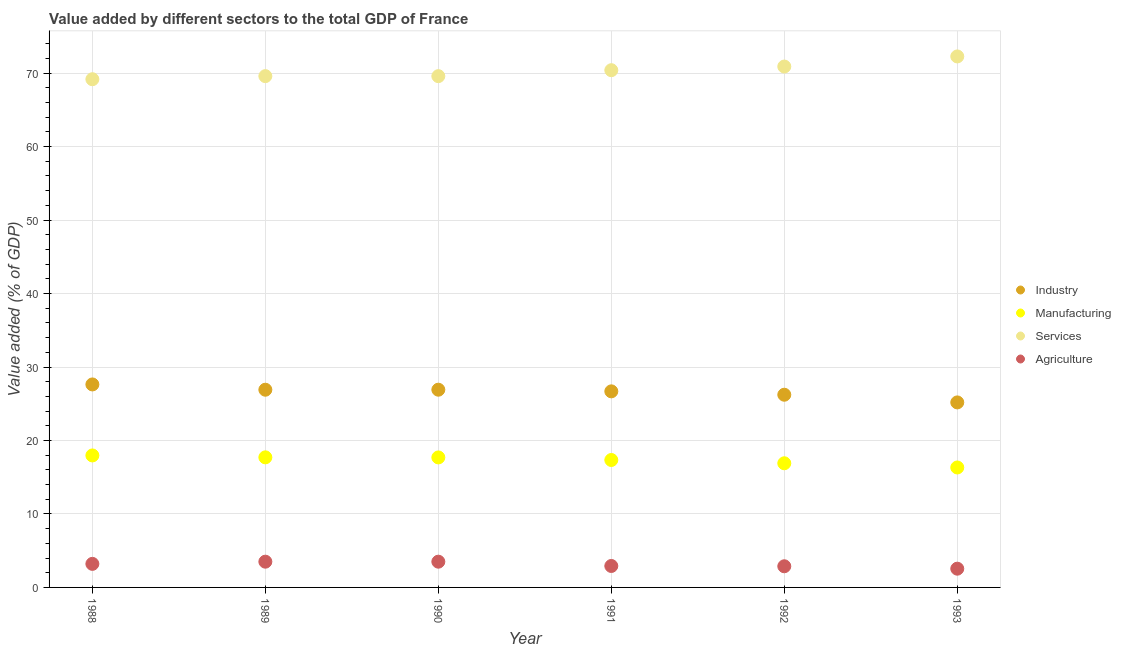How many different coloured dotlines are there?
Your answer should be very brief. 4. Is the number of dotlines equal to the number of legend labels?
Give a very brief answer. Yes. What is the value added by industrial sector in 1993?
Make the answer very short. 25.18. Across all years, what is the maximum value added by agricultural sector?
Ensure brevity in your answer.  3.5. Across all years, what is the minimum value added by agricultural sector?
Your answer should be compact. 2.55. In which year was the value added by industrial sector maximum?
Provide a succinct answer. 1988. What is the total value added by services sector in the graph?
Provide a succinct answer. 421.9. What is the difference between the value added by manufacturing sector in 1990 and that in 1993?
Your answer should be compact. 1.37. What is the difference between the value added by manufacturing sector in 1989 and the value added by services sector in 1991?
Your response must be concise. -52.69. What is the average value added by industrial sector per year?
Offer a very short reply. 26.59. In the year 1990, what is the difference between the value added by manufacturing sector and value added by agricultural sector?
Provide a succinct answer. 14.19. What is the ratio of the value added by services sector in 1990 to that in 1991?
Keep it short and to the point. 0.99. Is the value added by services sector in 1988 less than that in 1989?
Your response must be concise. Yes. Is the difference between the value added by industrial sector in 1988 and 1991 greater than the difference between the value added by services sector in 1988 and 1991?
Provide a succinct answer. Yes. What is the difference between the highest and the second highest value added by services sector?
Your answer should be very brief. 1.37. What is the difference between the highest and the lowest value added by industrial sector?
Provide a succinct answer. 2.45. In how many years, is the value added by services sector greater than the average value added by services sector taken over all years?
Your answer should be very brief. 3. Is it the case that in every year, the sum of the value added by industrial sector and value added by manufacturing sector is greater than the value added by services sector?
Offer a very short reply. No. Is the value added by agricultural sector strictly greater than the value added by manufacturing sector over the years?
Your answer should be compact. No. How many dotlines are there?
Give a very brief answer. 4. Are the values on the major ticks of Y-axis written in scientific E-notation?
Give a very brief answer. No. Where does the legend appear in the graph?
Your answer should be compact. Center right. How many legend labels are there?
Give a very brief answer. 4. What is the title of the graph?
Your answer should be compact. Value added by different sectors to the total GDP of France. What is the label or title of the X-axis?
Ensure brevity in your answer.  Year. What is the label or title of the Y-axis?
Offer a terse response. Value added (% of GDP). What is the Value added (% of GDP) in Industry in 1988?
Make the answer very short. 27.63. What is the Value added (% of GDP) in Manufacturing in 1988?
Keep it short and to the point. 17.96. What is the Value added (% of GDP) in Services in 1988?
Your answer should be compact. 69.17. What is the Value added (% of GDP) in Agriculture in 1988?
Your answer should be compact. 3.21. What is the Value added (% of GDP) of Industry in 1989?
Make the answer very short. 26.91. What is the Value added (% of GDP) in Manufacturing in 1989?
Offer a very short reply. 17.7. What is the Value added (% of GDP) of Services in 1989?
Provide a short and direct response. 69.59. What is the Value added (% of GDP) in Agriculture in 1989?
Ensure brevity in your answer.  3.5. What is the Value added (% of GDP) of Industry in 1990?
Make the answer very short. 26.91. What is the Value added (% of GDP) of Manufacturing in 1990?
Offer a very short reply. 17.69. What is the Value added (% of GDP) of Services in 1990?
Ensure brevity in your answer.  69.59. What is the Value added (% of GDP) in Agriculture in 1990?
Your response must be concise. 3.5. What is the Value added (% of GDP) in Industry in 1991?
Your answer should be compact. 26.69. What is the Value added (% of GDP) of Manufacturing in 1991?
Keep it short and to the point. 17.34. What is the Value added (% of GDP) in Services in 1991?
Your answer should be very brief. 70.4. What is the Value added (% of GDP) in Agriculture in 1991?
Your answer should be very brief. 2.92. What is the Value added (% of GDP) of Industry in 1992?
Keep it short and to the point. 26.23. What is the Value added (% of GDP) in Manufacturing in 1992?
Make the answer very short. 16.9. What is the Value added (% of GDP) of Services in 1992?
Your answer should be compact. 70.89. What is the Value added (% of GDP) of Agriculture in 1992?
Keep it short and to the point. 2.88. What is the Value added (% of GDP) of Industry in 1993?
Your response must be concise. 25.18. What is the Value added (% of GDP) of Manufacturing in 1993?
Give a very brief answer. 16.32. What is the Value added (% of GDP) of Services in 1993?
Your answer should be very brief. 72.27. What is the Value added (% of GDP) in Agriculture in 1993?
Provide a short and direct response. 2.55. Across all years, what is the maximum Value added (% of GDP) in Industry?
Your answer should be compact. 27.63. Across all years, what is the maximum Value added (% of GDP) in Manufacturing?
Offer a terse response. 17.96. Across all years, what is the maximum Value added (% of GDP) of Services?
Your answer should be very brief. 72.27. Across all years, what is the maximum Value added (% of GDP) of Agriculture?
Your answer should be very brief. 3.5. Across all years, what is the minimum Value added (% of GDP) of Industry?
Ensure brevity in your answer.  25.18. Across all years, what is the minimum Value added (% of GDP) in Manufacturing?
Give a very brief answer. 16.32. Across all years, what is the minimum Value added (% of GDP) of Services?
Keep it short and to the point. 69.17. Across all years, what is the minimum Value added (% of GDP) of Agriculture?
Your answer should be compact. 2.55. What is the total Value added (% of GDP) of Industry in the graph?
Ensure brevity in your answer.  159.54. What is the total Value added (% of GDP) of Manufacturing in the graph?
Provide a short and direct response. 103.92. What is the total Value added (% of GDP) in Services in the graph?
Your response must be concise. 421.9. What is the total Value added (% of GDP) in Agriculture in the graph?
Your response must be concise. 18.56. What is the difference between the Value added (% of GDP) of Industry in 1988 and that in 1989?
Your answer should be very brief. 0.72. What is the difference between the Value added (% of GDP) of Manufacturing in 1988 and that in 1989?
Provide a short and direct response. 0.26. What is the difference between the Value added (% of GDP) in Services in 1988 and that in 1989?
Your response must be concise. -0.42. What is the difference between the Value added (% of GDP) of Agriculture in 1988 and that in 1989?
Your answer should be compact. -0.3. What is the difference between the Value added (% of GDP) of Industry in 1988 and that in 1990?
Offer a terse response. 0.72. What is the difference between the Value added (% of GDP) in Manufacturing in 1988 and that in 1990?
Offer a very short reply. 0.27. What is the difference between the Value added (% of GDP) of Services in 1988 and that in 1990?
Your response must be concise. -0.42. What is the difference between the Value added (% of GDP) of Agriculture in 1988 and that in 1990?
Offer a very short reply. -0.3. What is the difference between the Value added (% of GDP) of Industry in 1988 and that in 1991?
Offer a terse response. 0.94. What is the difference between the Value added (% of GDP) of Manufacturing in 1988 and that in 1991?
Give a very brief answer. 0.62. What is the difference between the Value added (% of GDP) in Services in 1988 and that in 1991?
Your answer should be compact. -1.23. What is the difference between the Value added (% of GDP) in Agriculture in 1988 and that in 1991?
Offer a very short reply. 0.29. What is the difference between the Value added (% of GDP) of Industry in 1988 and that in 1992?
Give a very brief answer. 1.4. What is the difference between the Value added (% of GDP) in Manufacturing in 1988 and that in 1992?
Keep it short and to the point. 1.07. What is the difference between the Value added (% of GDP) of Services in 1988 and that in 1992?
Offer a terse response. -1.73. What is the difference between the Value added (% of GDP) in Agriculture in 1988 and that in 1992?
Give a very brief answer. 0.33. What is the difference between the Value added (% of GDP) of Industry in 1988 and that in 1993?
Keep it short and to the point. 2.45. What is the difference between the Value added (% of GDP) in Manufacturing in 1988 and that in 1993?
Offer a terse response. 1.64. What is the difference between the Value added (% of GDP) in Services in 1988 and that in 1993?
Ensure brevity in your answer.  -3.1. What is the difference between the Value added (% of GDP) in Agriculture in 1988 and that in 1993?
Provide a succinct answer. 0.66. What is the difference between the Value added (% of GDP) in Industry in 1989 and that in 1990?
Provide a succinct answer. -0. What is the difference between the Value added (% of GDP) in Manufacturing in 1989 and that in 1990?
Make the answer very short. 0.01. What is the difference between the Value added (% of GDP) in Services in 1989 and that in 1990?
Offer a terse response. 0. What is the difference between the Value added (% of GDP) of Agriculture in 1989 and that in 1990?
Keep it short and to the point. -0. What is the difference between the Value added (% of GDP) of Industry in 1989 and that in 1991?
Ensure brevity in your answer.  0.22. What is the difference between the Value added (% of GDP) in Manufacturing in 1989 and that in 1991?
Your response must be concise. 0.36. What is the difference between the Value added (% of GDP) in Services in 1989 and that in 1991?
Keep it short and to the point. -0.81. What is the difference between the Value added (% of GDP) of Agriculture in 1989 and that in 1991?
Ensure brevity in your answer.  0.58. What is the difference between the Value added (% of GDP) in Industry in 1989 and that in 1992?
Make the answer very short. 0.68. What is the difference between the Value added (% of GDP) of Manufacturing in 1989 and that in 1992?
Your response must be concise. 0.81. What is the difference between the Value added (% of GDP) in Services in 1989 and that in 1992?
Ensure brevity in your answer.  -1.31. What is the difference between the Value added (% of GDP) in Agriculture in 1989 and that in 1992?
Your answer should be very brief. 0.62. What is the difference between the Value added (% of GDP) of Industry in 1989 and that in 1993?
Make the answer very short. 1.73. What is the difference between the Value added (% of GDP) in Manufacturing in 1989 and that in 1993?
Your answer should be compact. 1.38. What is the difference between the Value added (% of GDP) in Services in 1989 and that in 1993?
Your answer should be very brief. -2.68. What is the difference between the Value added (% of GDP) in Agriculture in 1989 and that in 1993?
Your response must be concise. 0.95. What is the difference between the Value added (% of GDP) of Industry in 1990 and that in 1991?
Provide a succinct answer. 0.22. What is the difference between the Value added (% of GDP) of Manufacturing in 1990 and that in 1991?
Offer a terse response. 0.35. What is the difference between the Value added (% of GDP) of Services in 1990 and that in 1991?
Provide a short and direct response. -0.81. What is the difference between the Value added (% of GDP) in Agriculture in 1990 and that in 1991?
Your answer should be compact. 0.59. What is the difference between the Value added (% of GDP) of Industry in 1990 and that in 1992?
Provide a succinct answer. 0.68. What is the difference between the Value added (% of GDP) of Manufacturing in 1990 and that in 1992?
Make the answer very short. 0.8. What is the difference between the Value added (% of GDP) in Services in 1990 and that in 1992?
Your answer should be compact. -1.31. What is the difference between the Value added (% of GDP) in Agriculture in 1990 and that in 1992?
Your response must be concise. 0.62. What is the difference between the Value added (% of GDP) in Industry in 1990 and that in 1993?
Provide a succinct answer. 1.73. What is the difference between the Value added (% of GDP) of Manufacturing in 1990 and that in 1993?
Your answer should be compact. 1.37. What is the difference between the Value added (% of GDP) of Services in 1990 and that in 1993?
Give a very brief answer. -2.68. What is the difference between the Value added (% of GDP) of Agriculture in 1990 and that in 1993?
Give a very brief answer. 0.95. What is the difference between the Value added (% of GDP) in Industry in 1991 and that in 1992?
Make the answer very short. 0.46. What is the difference between the Value added (% of GDP) in Manufacturing in 1991 and that in 1992?
Provide a short and direct response. 0.45. What is the difference between the Value added (% of GDP) in Services in 1991 and that in 1992?
Your answer should be very brief. -0.5. What is the difference between the Value added (% of GDP) of Agriculture in 1991 and that in 1992?
Offer a very short reply. 0.04. What is the difference between the Value added (% of GDP) of Industry in 1991 and that in 1993?
Provide a succinct answer. 1.5. What is the difference between the Value added (% of GDP) of Manufacturing in 1991 and that in 1993?
Ensure brevity in your answer.  1.02. What is the difference between the Value added (% of GDP) of Services in 1991 and that in 1993?
Provide a succinct answer. -1.87. What is the difference between the Value added (% of GDP) in Agriculture in 1991 and that in 1993?
Make the answer very short. 0.37. What is the difference between the Value added (% of GDP) in Industry in 1992 and that in 1993?
Ensure brevity in your answer.  1.04. What is the difference between the Value added (% of GDP) in Manufacturing in 1992 and that in 1993?
Ensure brevity in your answer.  0.57. What is the difference between the Value added (% of GDP) in Services in 1992 and that in 1993?
Offer a very short reply. -1.37. What is the difference between the Value added (% of GDP) in Agriculture in 1992 and that in 1993?
Keep it short and to the point. 0.33. What is the difference between the Value added (% of GDP) in Industry in 1988 and the Value added (% of GDP) in Manufacturing in 1989?
Provide a short and direct response. 9.92. What is the difference between the Value added (% of GDP) of Industry in 1988 and the Value added (% of GDP) of Services in 1989?
Your answer should be compact. -41.96. What is the difference between the Value added (% of GDP) of Industry in 1988 and the Value added (% of GDP) of Agriculture in 1989?
Provide a short and direct response. 24.12. What is the difference between the Value added (% of GDP) in Manufacturing in 1988 and the Value added (% of GDP) in Services in 1989?
Make the answer very short. -51.63. What is the difference between the Value added (% of GDP) of Manufacturing in 1988 and the Value added (% of GDP) of Agriculture in 1989?
Your answer should be very brief. 14.46. What is the difference between the Value added (% of GDP) in Services in 1988 and the Value added (% of GDP) in Agriculture in 1989?
Offer a very short reply. 65.66. What is the difference between the Value added (% of GDP) of Industry in 1988 and the Value added (% of GDP) of Manufacturing in 1990?
Your response must be concise. 9.93. What is the difference between the Value added (% of GDP) of Industry in 1988 and the Value added (% of GDP) of Services in 1990?
Your answer should be very brief. -41.96. What is the difference between the Value added (% of GDP) in Industry in 1988 and the Value added (% of GDP) in Agriculture in 1990?
Keep it short and to the point. 24.12. What is the difference between the Value added (% of GDP) in Manufacturing in 1988 and the Value added (% of GDP) in Services in 1990?
Offer a very short reply. -51.62. What is the difference between the Value added (% of GDP) in Manufacturing in 1988 and the Value added (% of GDP) in Agriculture in 1990?
Provide a succinct answer. 14.46. What is the difference between the Value added (% of GDP) of Services in 1988 and the Value added (% of GDP) of Agriculture in 1990?
Keep it short and to the point. 65.66. What is the difference between the Value added (% of GDP) in Industry in 1988 and the Value added (% of GDP) in Manufacturing in 1991?
Offer a terse response. 10.28. What is the difference between the Value added (% of GDP) of Industry in 1988 and the Value added (% of GDP) of Services in 1991?
Make the answer very short. -42.77. What is the difference between the Value added (% of GDP) of Industry in 1988 and the Value added (% of GDP) of Agriculture in 1991?
Your response must be concise. 24.71. What is the difference between the Value added (% of GDP) in Manufacturing in 1988 and the Value added (% of GDP) in Services in 1991?
Give a very brief answer. -52.43. What is the difference between the Value added (% of GDP) of Manufacturing in 1988 and the Value added (% of GDP) of Agriculture in 1991?
Your answer should be very brief. 15.04. What is the difference between the Value added (% of GDP) of Services in 1988 and the Value added (% of GDP) of Agriculture in 1991?
Make the answer very short. 66.25. What is the difference between the Value added (% of GDP) in Industry in 1988 and the Value added (% of GDP) in Manufacturing in 1992?
Offer a terse response. 10.73. What is the difference between the Value added (% of GDP) of Industry in 1988 and the Value added (% of GDP) of Services in 1992?
Offer a terse response. -43.27. What is the difference between the Value added (% of GDP) of Industry in 1988 and the Value added (% of GDP) of Agriculture in 1992?
Provide a short and direct response. 24.75. What is the difference between the Value added (% of GDP) of Manufacturing in 1988 and the Value added (% of GDP) of Services in 1992?
Ensure brevity in your answer.  -52.93. What is the difference between the Value added (% of GDP) in Manufacturing in 1988 and the Value added (% of GDP) in Agriculture in 1992?
Provide a succinct answer. 15.08. What is the difference between the Value added (% of GDP) of Services in 1988 and the Value added (% of GDP) of Agriculture in 1992?
Keep it short and to the point. 66.29. What is the difference between the Value added (% of GDP) of Industry in 1988 and the Value added (% of GDP) of Manufacturing in 1993?
Provide a succinct answer. 11.3. What is the difference between the Value added (% of GDP) in Industry in 1988 and the Value added (% of GDP) in Services in 1993?
Offer a very short reply. -44.64. What is the difference between the Value added (% of GDP) in Industry in 1988 and the Value added (% of GDP) in Agriculture in 1993?
Offer a terse response. 25.08. What is the difference between the Value added (% of GDP) in Manufacturing in 1988 and the Value added (% of GDP) in Services in 1993?
Provide a short and direct response. -54.31. What is the difference between the Value added (% of GDP) of Manufacturing in 1988 and the Value added (% of GDP) of Agriculture in 1993?
Your answer should be compact. 15.41. What is the difference between the Value added (% of GDP) of Services in 1988 and the Value added (% of GDP) of Agriculture in 1993?
Your answer should be compact. 66.62. What is the difference between the Value added (% of GDP) of Industry in 1989 and the Value added (% of GDP) of Manufacturing in 1990?
Provide a short and direct response. 9.22. What is the difference between the Value added (% of GDP) in Industry in 1989 and the Value added (% of GDP) in Services in 1990?
Give a very brief answer. -42.68. What is the difference between the Value added (% of GDP) of Industry in 1989 and the Value added (% of GDP) of Agriculture in 1990?
Keep it short and to the point. 23.4. What is the difference between the Value added (% of GDP) in Manufacturing in 1989 and the Value added (% of GDP) in Services in 1990?
Keep it short and to the point. -51.88. What is the difference between the Value added (% of GDP) in Manufacturing in 1989 and the Value added (% of GDP) in Agriculture in 1990?
Give a very brief answer. 14.2. What is the difference between the Value added (% of GDP) of Services in 1989 and the Value added (% of GDP) of Agriculture in 1990?
Make the answer very short. 66.08. What is the difference between the Value added (% of GDP) in Industry in 1989 and the Value added (% of GDP) in Manufacturing in 1991?
Your answer should be compact. 9.56. What is the difference between the Value added (% of GDP) of Industry in 1989 and the Value added (% of GDP) of Services in 1991?
Your response must be concise. -43.49. What is the difference between the Value added (% of GDP) in Industry in 1989 and the Value added (% of GDP) in Agriculture in 1991?
Ensure brevity in your answer.  23.99. What is the difference between the Value added (% of GDP) in Manufacturing in 1989 and the Value added (% of GDP) in Services in 1991?
Provide a succinct answer. -52.69. What is the difference between the Value added (% of GDP) in Manufacturing in 1989 and the Value added (% of GDP) in Agriculture in 1991?
Offer a terse response. 14.79. What is the difference between the Value added (% of GDP) of Services in 1989 and the Value added (% of GDP) of Agriculture in 1991?
Provide a short and direct response. 66.67. What is the difference between the Value added (% of GDP) in Industry in 1989 and the Value added (% of GDP) in Manufacturing in 1992?
Your answer should be very brief. 10.01. What is the difference between the Value added (% of GDP) of Industry in 1989 and the Value added (% of GDP) of Services in 1992?
Ensure brevity in your answer.  -43.99. What is the difference between the Value added (% of GDP) of Industry in 1989 and the Value added (% of GDP) of Agriculture in 1992?
Provide a short and direct response. 24.03. What is the difference between the Value added (% of GDP) of Manufacturing in 1989 and the Value added (% of GDP) of Services in 1992?
Keep it short and to the point. -53.19. What is the difference between the Value added (% of GDP) in Manufacturing in 1989 and the Value added (% of GDP) in Agriculture in 1992?
Offer a terse response. 14.82. What is the difference between the Value added (% of GDP) of Services in 1989 and the Value added (% of GDP) of Agriculture in 1992?
Make the answer very short. 66.71. What is the difference between the Value added (% of GDP) of Industry in 1989 and the Value added (% of GDP) of Manufacturing in 1993?
Keep it short and to the point. 10.58. What is the difference between the Value added (% of GDP) in Industry in 1989 and the Value added (% of GDP) in Services in 1993?
Keep it short and to the point. -45.36. What is the difference between the Value added (% of GDP) of Industry in 1989 and the Value added (% of GDP) of Agriculture in 1993?
Make the answer very short. 24.36. What is the difference between the Value added (% of GDP) of Manufacturing in 1989 and the Value added (% of GDP) of Services in 1993?
Your answer should be very brief. -54.56. What is the difference between the Value added (% of GDP) in Manufacturing in 1989 and the Value added (% of GDP) in Agriculture in 1993?
Your response must be concise. 15.15. What is the difference between the Value added (% of GDP) in Services in 1989 and the Value added (% of GDP) in Agriculture in 1993?
Offer a terse response. 67.04. What is the difference between the Value added (% of GDP) in Industry in 1990 and the Value added (% of GDP) in Manufacturing in 1991?
Keep it short and to the point. 9.57. What is the difference between the Value added (% of GDP) of Industry in 1990 and the Value added (% of GDP) of Services in 1991?
Provide a succinct answer. -43.48. What is the difference between the Value added (% of GDP) in Industry in 1990 and the Value added (% of GDP) in Agriculture in 1991?
Offer a terse response. 23.99. What is the difference between the Value added (% of GDP) of Manufacturing in 1990 and the Value added (% of GDP) of Services in 1991?
Give a very brief answer. -52.7. What is the difference between the Value added (% of GDP) of Manufacturing in 1990 and the Value added (% of GDP) of Agriculture in 1991?
Ensure brevity in your answer.  14.77. What is the difference between the Value added (% of GDP) in Services in 1990 and the Value added (% of GDP) in Agriculture in 1991?
Keep it short and to the point. 66.67. What is the difference between the Value added (% of GDP) of Industry in 1990 and the Value added (% of GDP) of Manufacturing in 1992?
Ensure brevity in your answer.  10.01. What is the difference between the Value added (% of GDP) in Industry in 1990 and the Value added (% of GDP) in Services in 1992?
Your answer should be very brief. -43.98. What is the difference between the Value added (% of GDP) of Industry in 1990 and the Value added (% of GDP) of Agriculture in 1992?
Keep it short and to the point. 24.03. What is the difference between the Value added (% of GDP) in Manufacturing in 1990 and the Value added (% of GDP) in Services in 1992?
Give a very brief answer. -53.2. What is the difference between the Value added (% of GDP) of Manufacturing in 1990 and the Value added (% of GDP) of Agriculture in 1992?
Ensure brevity in your answer.  14.81. What is the difference between the Value added (% of GDP) in Services in 1990 and the Value added (% of GDP) in Agriculture in 1992?
Keep it short and to the point. 66.71. What is the difference between the Value added (% of GDP) of Industry in 1990 and the Value added (% of GDP) of Manufacturing in 1993?
Your answer should be compact. 10.59. What is the difference between the Value added (% of GDP) of Industry in 1990 and the Value added (% of GDP) of Services in 1993?
Offer a terse response. -45.36. What is the difference between the Value added (% of GDP) in Industry in 1990 and the Value added (% of GDP) in Agriculture in 1993?
Make the answer very short. 24.36. What is the difference between the Value added (% of GDP) of Manufacturing in 1990 and the Value added (% of GDP) of Services in 1993?
Provide a succinct answer. -54.58. What is the difference between the Value added (% of GDP) in Manufacturing in 1990 and the Value added (% of GDP) in Agriculture in 1993?
Ensure brevity in your answer.  15.14. What is the difference between the Value added (% of GDP) in Services in 1990 and the Value added (% of GDP) in Agriculture in 1993?
Make the answer very short. 67.03. What is the difference between the Value added (% of GDP) in Industry in 1991 and the Value added (% of GDP) in Manufacturing in 1992?
Your response must be concise. 9.79. What is the difference between the Value added (% of GDP) of Industry in 1991 and the Value added (% of GDP) of Services in 1992?
Give a very brief answer. -44.21. What is the difference between the Value added (% of GDP) in Industry in 1991 and the Value added (% of GDP) in Agriculture in 1992?
Provide a short and direct response. 23.81. What is the difference between the Value added (% of GDP) in Manufacturing in 1991 and the Value added (% of GDP) in Services in 1992?
Your answer should be compact. -53.55. What is the difference between the Value added (% of GDP) in Manufacturing in 1991 and the Value added (% of GDP) in Agriculture in 1992?
Provide a short and direct response. 14.46. What is the difference between the Value added (% of GDP) of Services in 1991 and the Value added (% of GDP) of Agriculture in 1992?
Provide a short and direct response. 67.52. What is the difference between the Value added (% of GDP) in Industry in 1991 and the Value added (% of GDP) in Manufacturing in 1993?
Your response must be concise. 10.36. What is the difference between the Value added (% of GDP) of Industry in 1991 and the Value added (% of GDP) of Services in 1993?
Your response must be concise. -45.58. What is the difference between the Value added (% of GDP) in Industry in 1991 and the Value added (% of GDP) in Agriculture in 1993?
Offer a very short reply. 24.14. What is the difference between the Value added (% of GDP) in Manufacturing in 1991 and the Value added (% of GDP) in Services in 1993?
Offer a terse response. -54.93. What is the difference between the Value added (% of GDP) of Manufacturing in 1991 and the Value added (% of GDP) of Agriculture in 1993?
Your response must be concise. 14.79. What is the difference between the Value added (% of GDP) of Services in 1991 and the Value added (% of GDP) of Agriculture in 1993?
Keep it short and to the point. 67.84. What is the difference between the Value added (% of GDP) of Industry in 1992 and the Value added (% of GDP) of Manufacturing in 1993?
Provide a succinct answer. 9.9. What is the difference between the Value added (% of GDP) in Industry in 1992 and the Value added (% of GDP) in Services in 1993?
Provide a succinct answer. -46.04. What is the difference between the Value added (% of GDP) in Industry in 1992 and the Value added (% of GDP) in Agriculture in 1993?
Your answer should be compact. 23.68. What is the difference between the Value added (% of GDP) of Manufacturing in 1992 and the Value added (% of GDP) of Services in 1993?
Provide a short and direct response. -55.37. What is the difference between the Value added (% of GDP) in Manufacturing in 1992 and the Value added (% of GDP) in Agriculture in 1993?
Offer a terse response. 14.35. What is the difference between the Value added (% of GDP) of Services in 1992 and the Value added (% of GDP) of Agriculture in 1993?
Ensure brevity in your answer.  68.34. What is the average Value added (% of GDP) in Industry per year?
Your answer should be compact. 26.59. What is the average Value added (% of GDP) of Manufacturing per year?
Provide a short and direct response. 17.32. What is the average Value added (% of GDP) of Services per year?
Your response must be concise. 70.32. What is the average Value added (% of GDP) in Agriculture per year?
Give a very brief answer. 3.09. In the year 1988, what is the difference between the Value added (% of GDP) in Industry and Value added (% of GDP) in Manufacturing?
Offer a very short reply. 9.66. In the year 1988, what is the difference between the Value added (% of GDP) of Industry and Value added (% of GDP) of Services?
Give a very brief answer. -41.54. In the year 1988, what is the difference between the Value added (% of GDP) in Industry and Value added (% of GDP) in Agriculture?
Your answer should be compact. 24.42. In the year 1988, what is the difference between the Value added (% of GDP) of Manufacturing and Value added (% of GDP) of Services?
Your answer should be compact. -51.2. In the year 1988, what is the difference between the Value added (% of GDP) in Manufacturing and Value added (% of GDP) in Agriculture?
Give a very brief answer. 14.76. In the year 1988, what is the difference between the Value added (% of GDP) of Services and Value added (% of GDP) of Agriculture?
Offer a very short reply. 65.96. In the year 1989, what is the difference between the Value added (% of GDP) in Industry and Value added (% of GDP) in Manufacturing?
Offer a terse response. 9.2. In the year 1989, what is the difference between the Value added (% of GDP) in Industry and Value added (% of GDP) in Services?
Offer a terse response. -42.68. In the year 1989, what is the difference between the Value added (% of GDP) in Industry and Value added (% of GDP) in Agriculture?
Offer a very short reply. 23.4. In the year 1989, what is the difference between the Value added (% of GDP) in Manufacturing and Value added (% of GDP) in Services?
Your response must be concise. -51.88. In the year 1989, what is the difference between the Value added (% of GDP) in Manufacturing and Value added (% of GDP) in Agriculture?
Give a very brief answer. 14.2. In the year 1989, what is the difference between the Value added (% of GDP) of Services and Value added (% of GDP) of Agriculture?
Make the answer very short. 66.09. In the year 1990, what is the difference between the Value added (% of GDP) in Industry and Value added (% of GDP) in Manufacturing?
Ensure brevity in your answer.  9.22. In the year 1990, what is the difference between the Value added (% of GDP) in Industry and Value added (% of GDP) in Services?
Keep it short and to the point. -42.67. In the year 1990, what is the difference between the Value added (% of GDP) in Industry and Value added (% of GDP) in Agriculture?
Make the answer very short. 23.41. In the year 1990, what is the difference between the Value added (% of GDP) of Manufacturing and Value added (% of GDP) of Services?
Offer a terse response. -51.89. In the year 1990, what is the difference between the Value added (% of GDP) of Manufacturing and Value added (% of GDP) of Agriculture?
Ensure brevity in your answer.  14.19. In the year 1990, what is the difference between the Value added (% of GDP) in Services and Value added (% of GDP) in Agriculture?
Give a very brief answer. 66.08. In the year 1991, what is the difference between the Value added (% of GDP) of Industry and Value added (% of GDP) of Manufacturing?
Your response must be concise. 9.34. In the year 1991, what is the difference between the Value added (% of GDP) in Industry and Value added (% of GDP) in Services?
Provide a short and direct response. -43.71. In the year 1991, what is the difference between the Value added (% of GDP) of Industry and Value added (% of GDP) of Agriculture?
Your answer should be compact. 23.77. In the year 1991, what is the difference between the Value added (% of GDP) of Manufacturing and Value added (% of GDP) of Services?
Offer a very short reply. -53.05. In the year 1991, what is the difference between the Value added (% of GDP) in Manufacturing and Value added (% of GDP) in Agriculture?
Offer a very short reply. 14.42. In the year 1991, what is the difference between the Value added (% of GDP) of Services and Value added (% of GDP) of Agriculture?
Offer a terse response. 67.48. In the year 1992, what is the difference between the Value added (% of GDP) of Industry and Value added (% of GDP) of Manufacturing?
Your answer should be very brief. 9.33. In the year 1992, what is the difference between the Value added (% of GDP) in Industry and Value added (% of GDP) in Services?
Ensure brevity in your answer.  -44.67. In the year 1992, what is the difference between the Value added (% of GDP) in Industry and Value added (% of GDP) in Agriculture?
Your answer should be very brief. 23.35. In the year 1992, what is the difference between the Value added (% of GDP) of Manufacturing and Value added (% of GDP) of Services?
Your response must be concise. -54. In the year 1992, what is the difference between the Value added (% of GDP) of Manufacturing and Value added (% of GDP) of Agriculture?
Your answer should be compact. 14.02. In the year 1992, what is the difference between the Value added (% of GDP) in Services and Value added (% of GDP) in Agriculture?
Offer a terse response. 68.01. In the year 1993, what is the difference between the Value added (% of GDP) of Industry and Value added (% of GDP) of Manufacturing?
Keep it short and to the point. 8.86. In the year 1993, what is the difference between the Value added (% of GDP) of Industry and Value added (% of GDP) of Services?
Give a very brief answer. -47.09. In the year 1993, what is the difference between the Value added (% of GDP) in Industry and Value added (% of GDP) in Agriculture?
Keep it short and to the point. 22.63. In the year 1993, what is the difference between the Value added (% of GDP) of Manufacturing and Value added (% of GDP) of Services?
Offer a very short reply. -55.94. In the year 1993, what is the difference between the Value added (% of GDP) in Manufacturing and Value added (% of GDP) in Agriculture?
Your response must be concise. 13.77. In the year 1993, what is the difference between the Value added (% of GDP) of Services and Value added (% of GDP) of Agriculture?
Keep it short and to the point. 69.72. What is the ratio of the Value added (% of GDP) in Industry in 1988 to that in 1989?
Provide a short and direct response. 1.03. What is the ratio of the Value added (% of GDP) in Manufacturing in 1988 to that in 1989?
Ensure brevity in your answer.  1.01. What is the ratio of the Value added (% of GDP) of Services in 1988 to that in 1989?
Give a very brief answer. 0.99. What is the ratio of the Value added (% of GDP) in Agriculture in 1988 to that in 1989?
Offer a very short reply. 0.92. What is the ratio of the Value added (% of GDP) in Industry in 1988 to that in 1990?
Provide a succinct answer. 1.03. What is the ratio of the Value added (% of GDP) of Manufacturing in 1988 to that in 1990?
Offer a terse response. 1.02. What is the ratio of the Value added (% of GDP) of Agriculture in 1988 to that in 1990?
Offer a terse response. 0.92. What is the ratio of the Value added (% of GDP) of Industry in 1988 to that in 1991?
Provide a short and direct response. 1.04. What is the ratio of the Value added (% of GDP) of Manufacturing in 1988 to that in 1991?
Ensure brevity in your answer.  1.04. What is the ratio of the Value added (% of GDP) in Services in 1988 to that in 1991?
Provide a short and direct response. 0.98. What is the ratio of the Value added (% of GDP) in Agriculture in 1988 to that in 1991?
Provide a short and direct response. 1.1. What is the ratio of the Value added (% of GDP) in Industry in 1988 to that in 1992?
Your answer should be compact. 1.05. What is the ratio of the Value added (% of GDP) in Manufacturing in 1988 to that in 1992?
Keep it short and to the point. 1.06. What is the ratio of the Value added (% of GDP) of Services in 1988 to that in 1992?
Your answer should be compact. 0.98. What is the ratio of the Value added (% of GDP) in Agriculture in 1988 to that in 1992?
Your answer should be compact. 1.11. What is the ratio of the Value added (% of GDP) of Industry in 1988 to that in 1993?
Ensure brevity in your answer.  1.1. What is the ratio of the Value added (% of GDP) of Manufacturing in 1988 to that in 1993?
Offer a terse response. 1.1. What is the ratio of the Value added (% of GDP) in Services in 1988 to that in 1993?
Give a very brief answer. 0.96. What is the ratio of the Value added (% of GDP) of Agriculture in 1988 to that in 1993?
Offer a very short reply. 1.26. What is the ratio of the Value added (% of GDP) of Industry in 1989 to that in 1990?
Give a very brief answer. 1. What is the ratio of the Value added (% of GDP) of Services in 1989 to that in 1990?
Offer a terse response. 1. What is the ratio of the Value added (% of GDP) in Industry in 1989 to that in 1991?
Keep it short and to the point. 1.01. What is the ratio of the Value added (% of GDP) in Manufacturing in 1989 to that in 1991?
Ensure brevity in your answer.  1.02. What is the ratio of the Value added (% of GDP) in Agriculture in 1989 to that in 1991?
Give a very brief answer. 1.2. What is the ratio of the Value added (% of GDP) in Industry in 1989 to that in 1992?
Provide a short and direct response. 1.03. What is the ratio of the Value added (% of GDP) of Manufacturing in 1989 to that in 1992?
Ensure brevity in your answer.  1.05. What is the ratio of the Value added (% of GDP) in Services in 1989 to that in 1992?
Give a very brief answer. 0.98. What is the ratio of the Value added (% of GDP) in Agriculture in 1989 to that in 1992?
Provide a short and direct response. 1.22. What is the ratio of the Value added (% of GDP) in Industry in 1989 to that in 1993?
Provide a short and direct response. 1.07. What is the ratio of the Value added (% of GDP) in Manufacturing in 1989 to that in 1993?
Provide a short and direct response. 1.08. What is the ratio of the Value added (% of GDP) in Services in 1989 to that in 1993?
Your response must be concise. 0.96. What is the ratio of the Value added (% of GDP) in Agriculture in 1989 to that in 1993?
Keep it short and to the point. 1.37. What is the ratio of the Value added (% of GDP) in Industry in 1990 to that in 1991?
Your answer should be compact. 1.01. What is the ratio of the Value added (% of GDP) in Manufacturing in 1990 to that in 1991?
Provide a succinct answer. 1.02. What is the ratio of the Value added (% of GDP) in Services in 1990 to that in 1991?
Your response must be concise. 0.99. What is the ratio of the Value added (% of GDP) in Agriculture in 1990 to that in 1991?
Your response must be concise. 1.2. What is the ratio of the Value added (% of GDP) of Industry in 1990 to that in 1992?
Make the answer very short. 1.03. What is the ratio of the Value added (% of GDP) of Manufacturing in 1990 to that in 1992?
Keep it short and to the point. 1.05. What is the ratio of the Value added (% of GDP) of Services in 1990 to that in 1992?
Offer a very short reply. 0.98. What is the ratio of the Value added (% of GDP) of Agriculture in 1990 to that in 1992?
Your answer should be very brief. 1.22. What is the ratio of the Value added (% of GDP) of Industry in 1990 to that in 1993?
Provide a short and direct response. 1.07. What is the ratio of the Value added (% of GDP) in Manufacturing in 1990 to that in 1993?
Ensure brevity in your answer.  1.08. What is the ratio of the Value added (% of GDP) of Services in 1990 to that in 1993?
Offer a very short reply. 0.96. What is the ratio of the Value added (% of GDP) of Agriculture in 1990 to that in 1993?
Ensure brevity in your answer.  1.37. What is the ratio of the Value added (% of GDP) in Industry in 1991 to that in 1992?
Keep it short and to the point. 1.02. What is the ratio of the Value added (% of GDP) in Manufacturing in 1991 to that in 1992?
Your response must be concise. 1.03. What is the ratio of the Value added (% of GDP) in Agriculture in 1991 to that in 1992?
Give a very brief answer. 1.01. What is the ratio of the Value added (% of GDP) of Industry in 1991 to that in 1993?
Make the answer very short. 1.06. What is the ratio of the Value added (% of GDP) in Manufacturing in 1991 to that in 1993?
Offer a terse response. 1.06. What is the ratio of the Value added (% of GDP) in Services in 1991 to that in 1993?
Provide a short and direct response. 0.97. What is the ratio of the Value added (% of GDP) of Agriculture in 1991 to that in 1993?
Offer a very short reply. 1.14. What is the ratio of the Value added (% of GDP) in Industry in 1992 to that in 1993?
Provide a succinct answer. 1.04. What is the ratio of the Value added (% of GDP) of Manufacturing in 1992 to that in 1993?
Ensure brevity in your answer.  1.04. What is the ratio of the Value added (% of GDP) in Services in 1992 to that in 1993?
Offer a very short reply. 0.98. What is the ratio of the Value added (% of GDP) in Agriculture in 1992 to that in 1993?
Offer a very short reply. 1.13. What is the difference between the highest and the second highest Value added (% of GDP) in Industry?
Your response must be concise. 0.72. What is the difference between the highest and the second highest Value added (% of GDP) in Manufacturing?
Ensure brevity in your answer.  0.26. What is the difference between the highest and the second highest Value added (% of GDP) in Services?
Provide a succinct answer. 1.37. What is the difference between the highest and the second highest Value added (% of GDP) in Agriculture?
Make the answer very short. 0. What is the difference between the highest and the lowest Value added (% of GDP) in Industry?
Offer a terse response. 2.45. What is the difference between the highest and the lowest Value added (% of GDP) of Manufacturing?
Offer a very short reply. 1.64. What is the difference between the highest and the lowest Value added (% of GDP) in Services?
Keep it short and to the point. 3.1. What is the difference between the highest and the lowest Value added (% of GDP) of Agriculture?
Your answer should be compact. 0.95. 